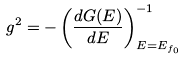<formula> <loc_0><loc_0><loc_500><loc_500>g ^ { 2 } = - \left ( \frac { d G ( E ) } { d E } \right ) ^ { - 1 } _ { E = E _ { f _ { 0 } } }</formula> 